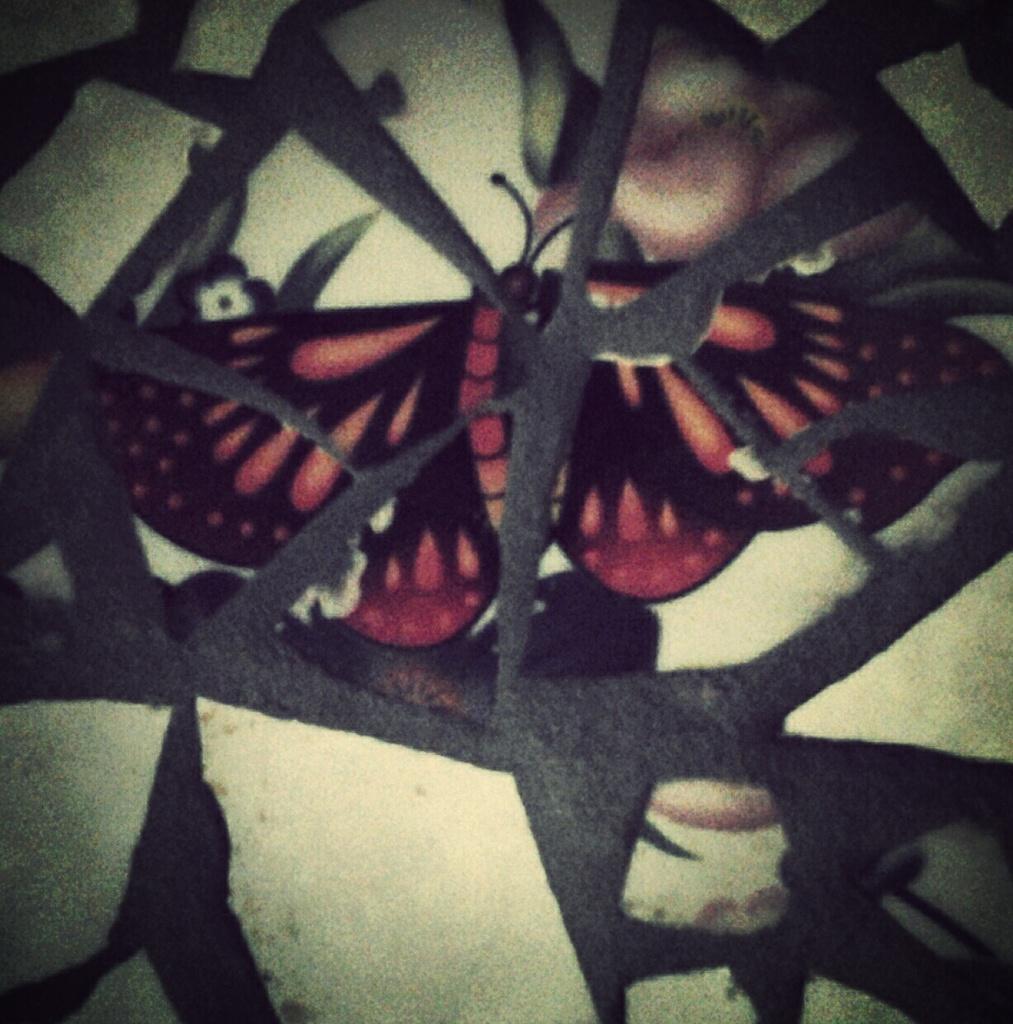Can you describe this image briefly? In this image we can see the wall, on the wall we can see some design of a butterfly and flowers. 